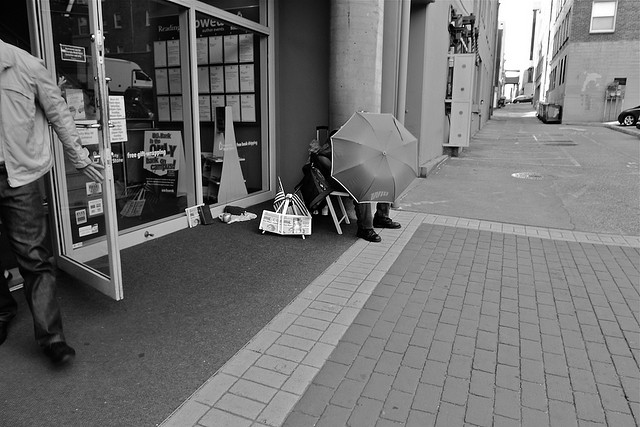Please identify all text content in this image. OW 